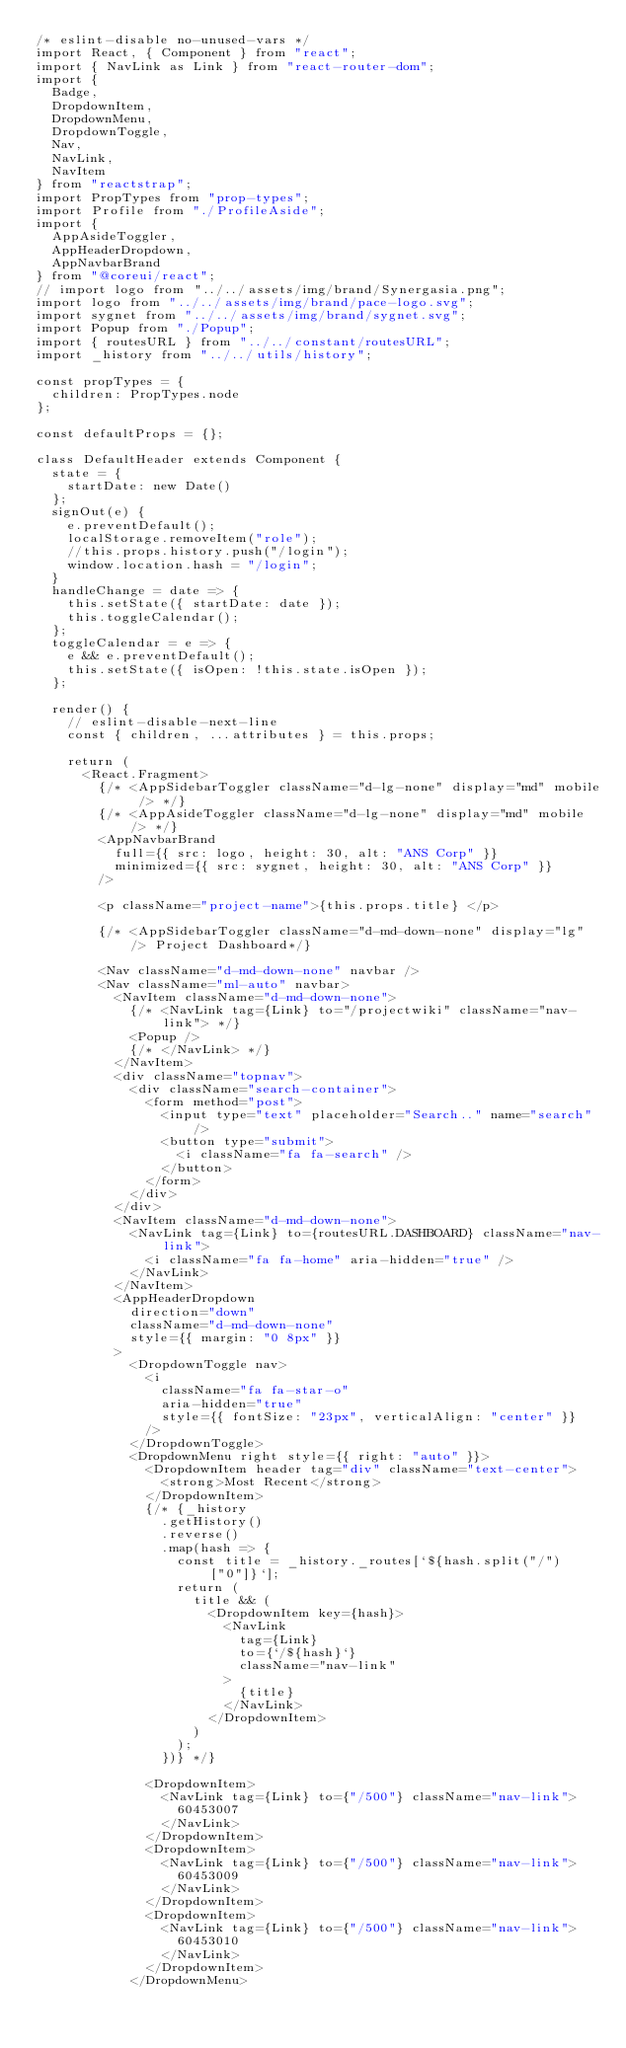<code> <loc_0><loc_0><loc_500><loc_500><_JavaScript_>/* eslint-disable no-unused-vars */
import React, { Component } from "react";
import { NavLink as Link } from "react-router-dom";
import {
  Badge,
  DropdownItem,
  DropdownMenu,
  DropdownToggle,
  Nav,
  NavLink,
  NavItem
} from "reactstrap";
import PropTypes from "prop-types";
import Profile from "./ProfileAside";
import {
  AppAsideToggler,
  AppHeaderDropdown,
  AppNavbarBrand
} from "@coreui/react";
// import logo from "../../assets/img/brand/Synergasia.png";
import logo from "../../assets/img/brand/pace-logo.svg";
import sygnet from "../../assets/img/brand/sygnet.svg";
import Popup from "./Popup";
import { routesURL } from "../../constant/routesURL";
import _history from "../../utils/history";

const propTypes = {
  children: PropTypes.node
};

const defaultProps = {};

class DefaultHeader extends Component {
  state = {
    startDate: new Date()
  };
  signOut(e) {
    e.preventDefault();
    localStorage.removeItem("role");
    //this.props.history.push("/login");
    window.location.hash = "/login";
  }
  handleChange = date => {
    this.setState({ startDate: date });
    this.toggleCalendar();
  };
  toggleCalendar = e => {
    e && e.preventDefault();
    this.setState({ isOpen: !this.state.isOpen });
  };

  render() {
    // eslint-disable-next-line
    const { children, ...attributes } = this.props;

    return (
      <React.Fragment>
        {/* <AppSidebarToggler className="d-lg-none" display="md" mobile /> */}
        {/* <AppAsideToggler className="d-lg-none" display="md" mobile /> */}
        <AppNavbarBrand
          full={{ src: logo, height: 30, alt: "ANS Corp" }}
          minimized={{ src: sygnet, height: 30, alt: "ANS Corp" }}
        />

        <p className="project-name">{this.props.title} </p>

        {/* <AppSidebarToggler className="d-md-down-none" display="lg" /> Project Dashboard*/}

        <Nav className="d-md-down-none" navbar />
        <Nav className="ml-auto" navbar>
          <NavItem className="d-md-down-none">
            {/* <NavLink tag={Link} to="/projectwiki" className="nav-link"> */}
            <Popup />
            {/* </NavLink> */}
          </NavItem>
          <div className="topnav">
            <div className="search-container">
              <form method="post">
                <input type="text" placeholder="Search.." name="search" />
                <button type="submit">
                  <i className="fa fa-search" />
                </button>
              </form>
            </div>
          </div>
          <NavItem className="d-md-down-none">
            <NavLink tag={Link} to={routesURL.DASHBOARD} className="nav-link">
              <i className="fa fa-home" aria-hidden="true" />
            </NavLink>
          </NavItem>
          <AppHeaderDropdown
            direction="down"
            className="d-md-down-none"
            style={{ margin: "0 8px" }}
          >
            <DropdownToggle nav>
              <i
                className="fa fa-star-o"
                aria-hidden="true"
                style={{ fontSize: "23px", verticalAlign: "center" }}
              />
            </DropdownToggle>
            <DropdownMenu right style={{ right: "auto" }}>
              <DropdownItem header tag="div" className="text-center">
                <strong>Most Recent</strong>
              </DropdownItem>
              {/* {_history
                .getHistory()
                .reverse()
                .map(hash => {
                  const title = _history._routes[`${hash.split("/")["0"]}`];
                  return (
                    title && (
                      <DropdownItem key={hash}>
                        <NavLink
                          tag={Link}
                          to={`/${hash}`}
                          className="nav-link"
                        >
                          {title}
                        </NavLink>
                      </DropdownItem>
                    )
                  );
                })} */}

              <DropdownItem>
                <NavLink tag={Link} to={"/500"} className="nav-link">
                  60453007
                </NavLink>
              </DropdownItem>
              <DropdownItem>
                <NavLink tag={Link} to={"/500"} className="nav-link">
                  60453009
                </NavLink>
              </DropdownItem>
              <DropdownItem>
                <NavLink tag={Link} to={"/500"} className="nav-link">
                  60453010
                </NavLink>
              </DropdownItem>
            </DropdownMenu></code> 